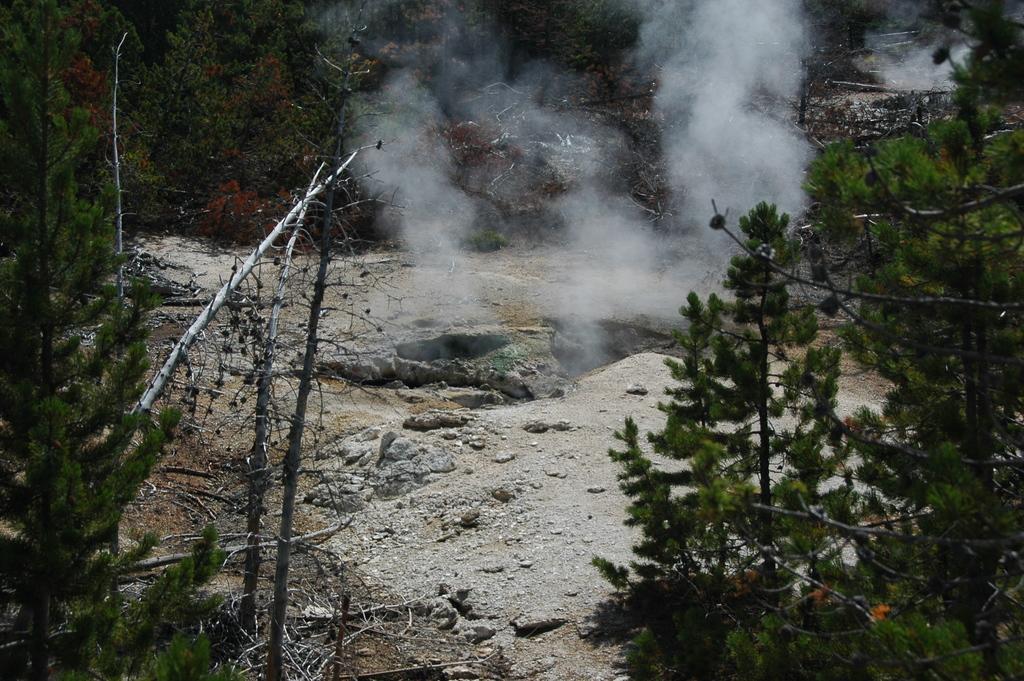How would you summarize this image in a sentence or two? In this picture there are few rocks and there are trees around it. 